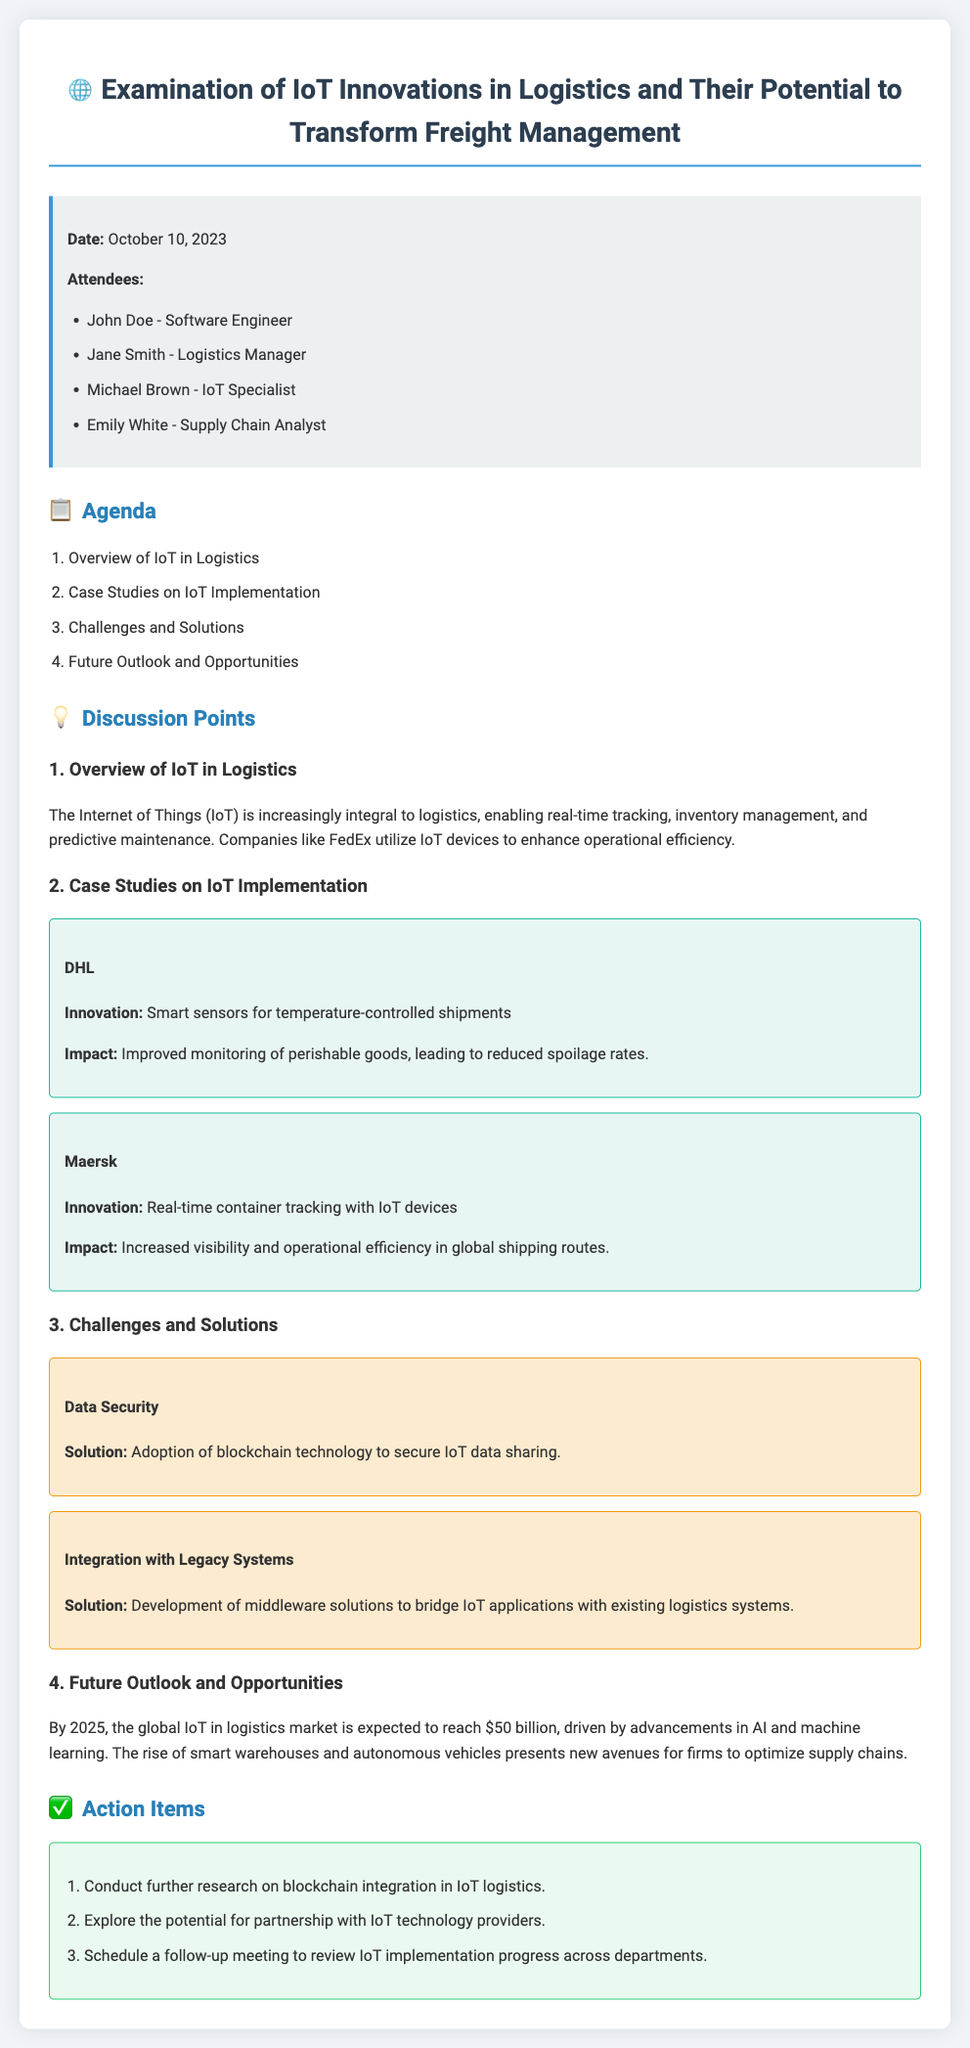What is the date of the meeting? The meeting took place on October 10, 2023.
Answer: October 10, 2023 Who is the Logistics Manager? The document lists Jane Smith as the Logistics Manager.
Answer: Jane Smith What is one innovation used by DHL? The document states that DHL uses smart sensors for temperature-controlled shipments.
Answer: Smart sensors for temperature-controlled shipments What is the expected market size for IoT in logistics by 2025? The document indicates that the global IoT in logistics market is expected to reach $50 billion by 2025.
Answer: $50 billion What solution was proposed for data security challenges? The solution defined in the document is the adoption of blockchain technology.
Answer: Adoption of blockchain technology Which company is mentioned for real-time container tracking? The document mentions Maersk for its innovation in real-time container tracking.
Answer: Maersk How many action items were listed in the meeting? The document states that there are three action items listed.
Answer: Three What was one challenge discussed regarding IoT in logistics? The document discusses data security as one of the challenges.
Answer: Data security Who is the IoT Specialist mentioned in the meeting? Michael Brown is listed as the IoT Specialist in the document.
Answer: Michael Brown 